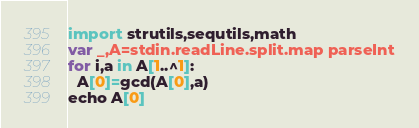<code> <loc_0><loc_0><loc_500><loc_500><_Nim_>import strutils,sequtils,math
var _,A=stdin.readLine.split.map parseInt
for i,a in A[1..^1]:
  A[0]=gcd(A[0],a)
echo A[0]</code> 